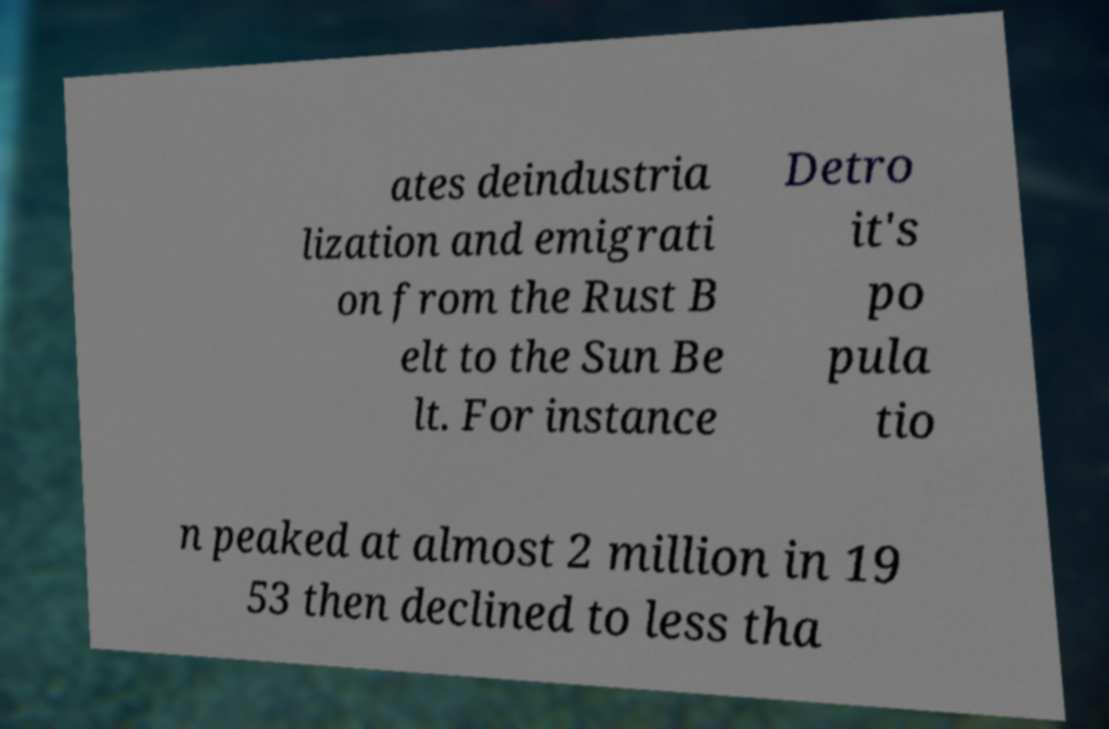Please identify and transcribe the text found in this image. ates deindustria lization and emigrati on from the Rust B elt to the Sun Be lt. For instance Detro it's po pula tio n peaked at almost 2 million in 19 53 then declined to less tha 